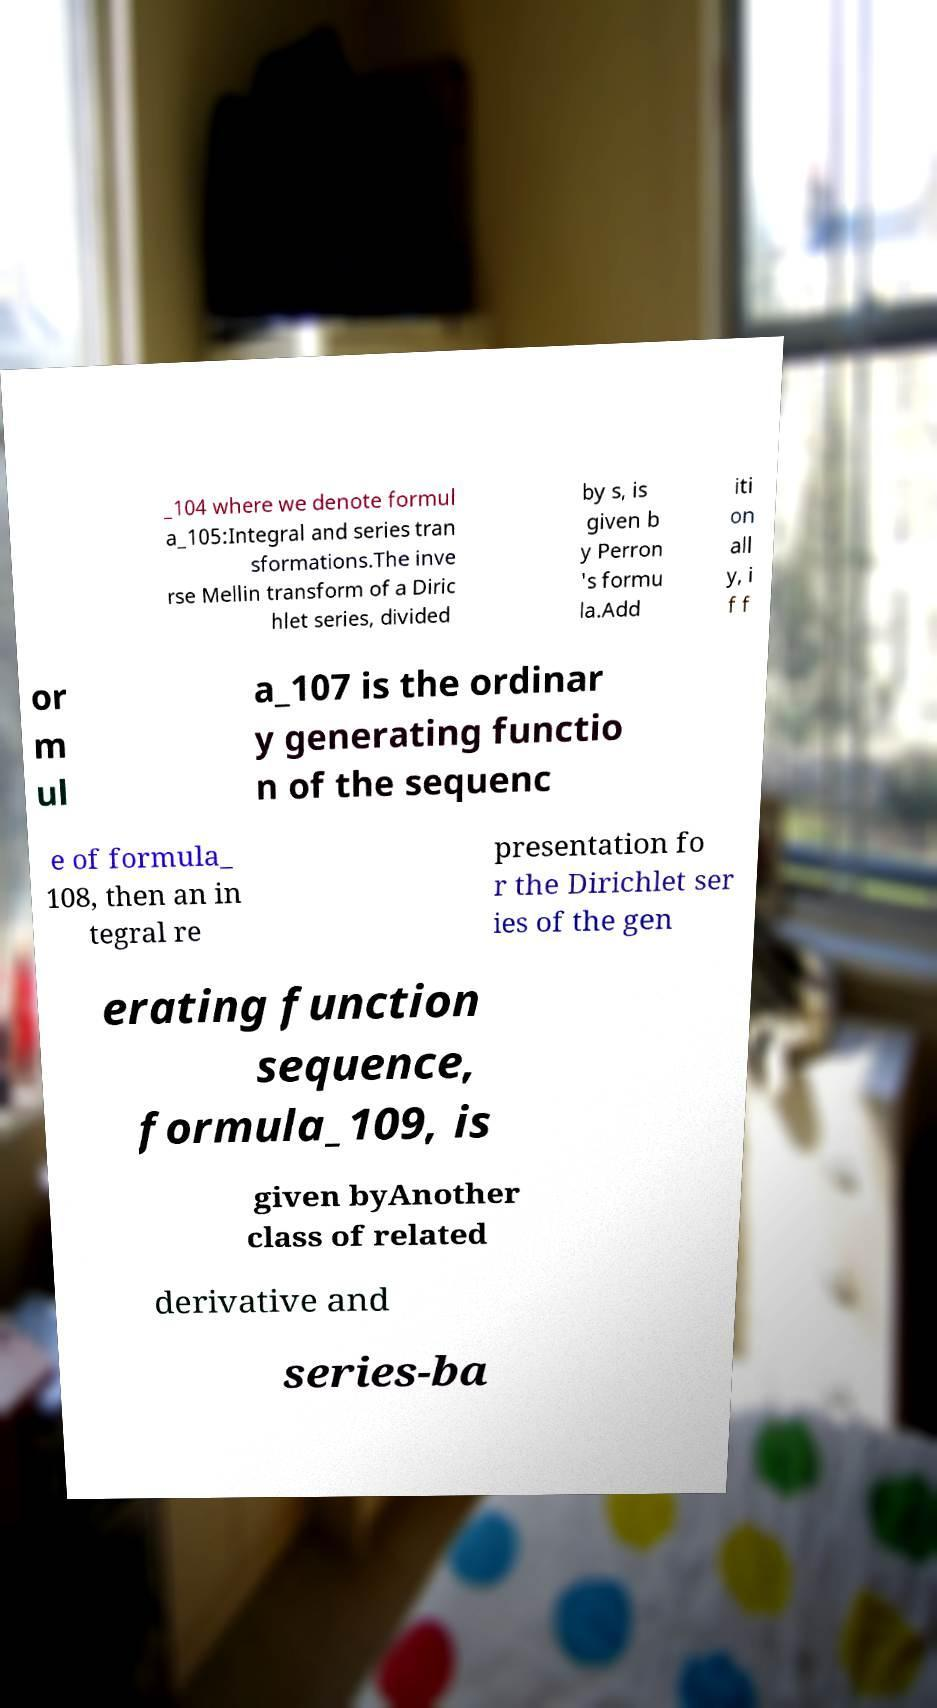Could you extract and type out the text from this image? _104 where we denote formul a_105:Integral and series tran sformations.The inve rse Mellin transform of a Diric hlet series, divided by s, is given b y Perron 's formu la.Add iti on all y, i f f or m ul a_107 is the ordinar y generating functio n of the sequenc e of formula_ 108, then an in tegral re presentation fo r the Dirichlet ser ies of the gen erating function sequence, formula_109, is given byAnother class of related derivative and series-ba 